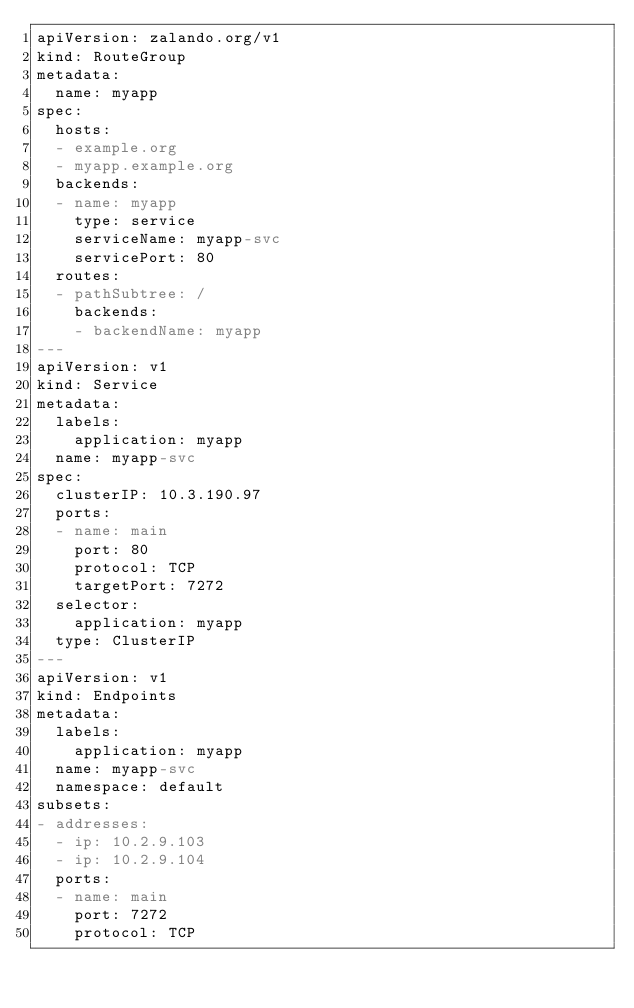<code> <loc_0><loc_0><loc_500><loc_500><_YAML_>apiVersion: zalando.org/v1
kind: RouteGroup
metadata:
  name: myapp
spec:
  hosts:
  - example.org
  - myapp.example.org
  backends:
  - name: myapp
    type: service
    serviceName: myapp-svc
    servicePort: 80
  routes:
  - pathSubtree: /
    backends:
    - backendName: myapp
---
apiVersion: v1
kind: Service
metadata:
  labels:
    application: myapp
  name: myapp-svc
spec:
  clusterIP: 10.3.190.97
  ports:
  - name: main
    port: 80
    protocol: TCP
    targetPort: 7272
  selector:
    application: myapp
  type: ClusterIP
---
apiVersion: v1
kind: Endpoints
metadata:
  labels:
    application: myapp
  name: myapp-svc
  namespace: default
subsets:
- addresses:
  - ip: 10.2.9.103
  - ip: 10.2.9.104
  ports:
  - name: main
    port: 7272
    protocol: TCP
</code> 